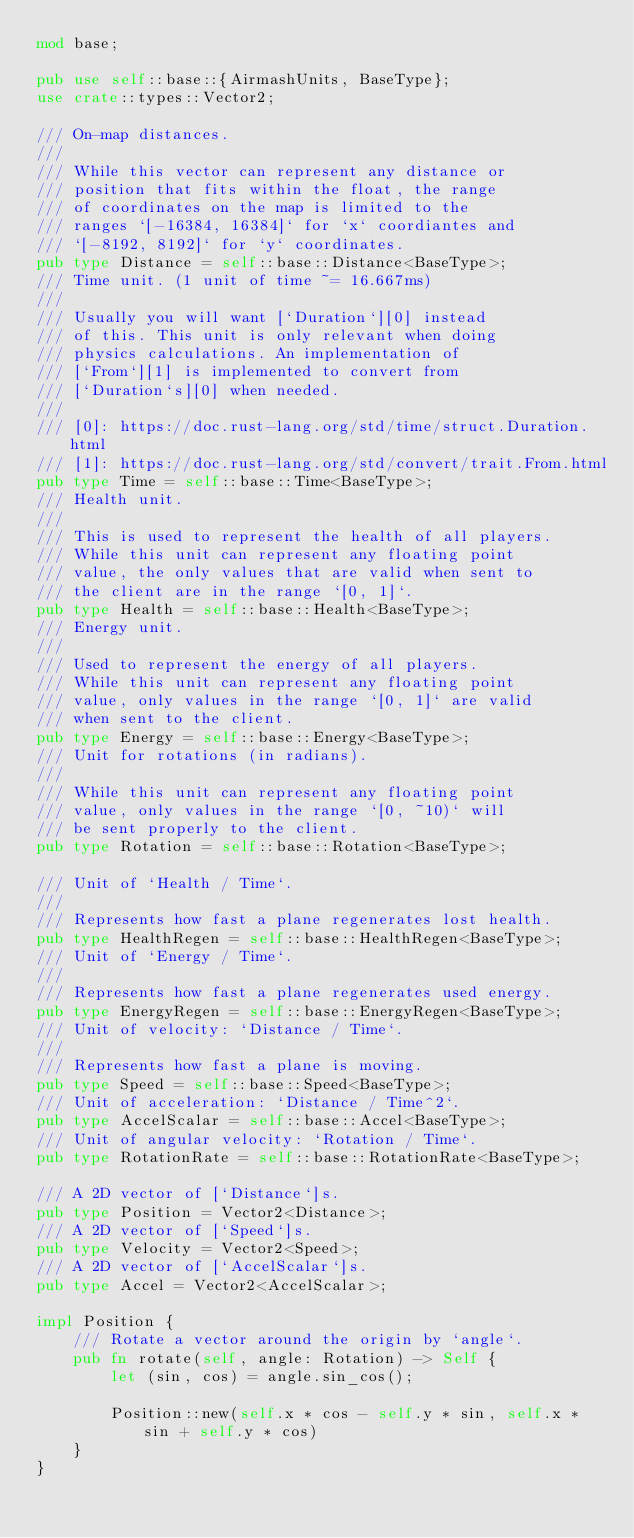<code> <loc_0><loc_0><loc_500><loc_500><_Rust_>mod base;

pub use self::base::{AirmashUnits, BaseType};
use crate::types::Vector2;

/// On-map distances.
///
/// While this vector can represent any distance or
/// position that fits within the float, the range
/// of coordinates on the map is limited to the
/// ranges `[-16384, 16384]` for `x` coordiantes and
/// `[-8192, 8192]` for `y` coordinates.
pub type Distance = self::base::Distance<BaseType>;
/// Time unit. (1 unit of time ~= 16.667ms)
///
/// Usually you will want [`Duration`][0] instead
/// of this. This unit is only relevant when doing
/// physics calculations. An implementation of
/// [`From`][1] is implemented to convert from
/// [`Duration`s][0] when needed.
///
/// [0]: https://doc.rust-lang.org/std/time/struct.Duration.html
/// [1]: https://doc.rust-lang.org/std/convert/trait.From.html
pub type Time = self::base::Time<BaseType>;
/// Health unit.
///
/// This is used to represent the health of all players.
/// While this unit can represent any floating point
/// value, the only values that are valid when sent to
/// the client are in the range `[0, 1]`.
pub type Health = self::base::Health<BaseType>;
/// Energy unit.
///
/// Used to represent the energy of all players.
/// While this unit can represent any floating point
/// value, only values in the range `[0, 1]` are valid
/// when sent to the client.
pub type Energy = self::base::Energy<BaseType>;
/// Unit for rotations (in radians).
///
/// While this unit can represent any floating point
/// value, only values in the range `[0, ~10)` will
/// be sent properly to the client.
pub type Rotation = self::base::Rotation<BaseType>;

/// Unit of `Health / Time`.
///
/// Represents how fast a plane regenerates lost health.
pub type HealthRegen = self::base::HealthRegen<BaseType>;
/// Unit of `Energy / Time`.
///
/// Represents how fast a plane regenerates used energy.
pub type EnergyRegen = self::base::EnergyRegen<BaseType>;
/// Unit of velocity: `Distance / Time`.
///
/// Represents how fast a plane is moving.
pub type Speed = self::base::Speed<BaseType>;
/// Unit of acceleration: `Distance / Time^2`.
pub type AccelScalar = self::base::Accel<BaseType>;
/// Unit of angular velocity: `Rotation / Time`.
pub type RotationRate = self::base::RotationRate<BaseType>;

/// A 2D vector of [`Distance`]s.
pub type Position = Vector2<Distance>;
/// A 2D vector of [`Speed`]s.
pub type Velocity = Vector2<Speed>;
/// A 2D vector of [`AccelScalar`]s.
pub type Accel = Vector2<AccelScalar>;

impl Position {
	/// Rotate a vector around the origin by `angle`.
	pub fn rotate(self, angle: Rotation) -> Self {
		let (sin, cos) = angle.sin_cos();

		Position::new(self.x * cos - self.y * sin, self.x * sin + self.y * cos)
	}
}
</code> 